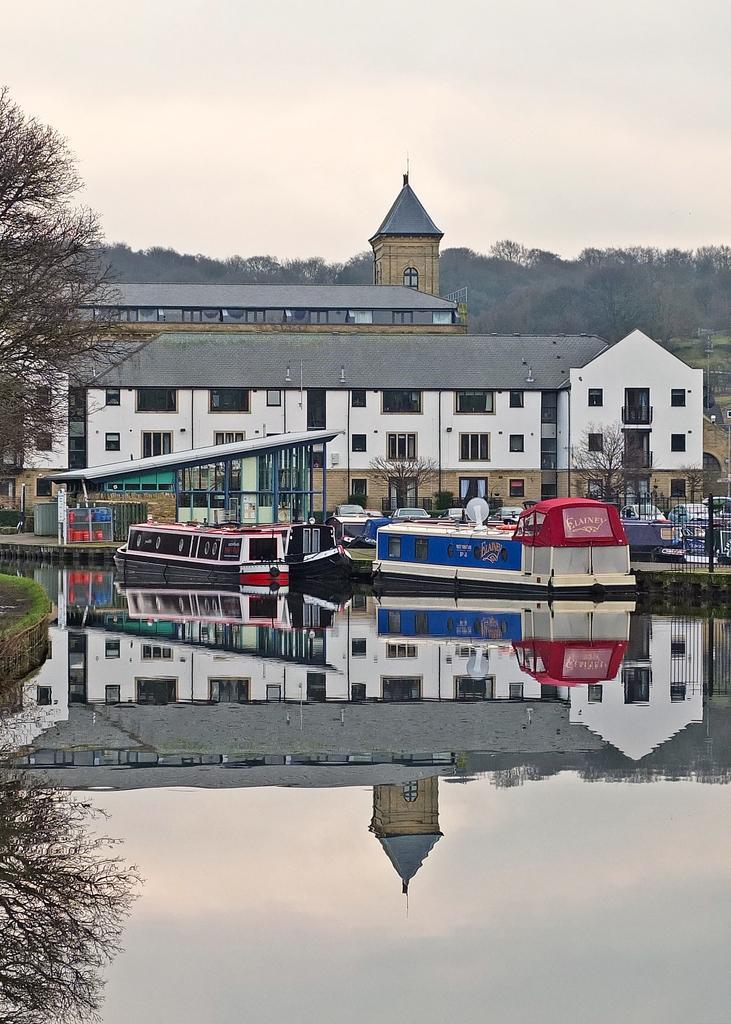Please provide a concise description of this image. In this picture we can see water. There is the reflection of a building and a tree in the water. We can see a few plants and a wall on the left side. There is a fence, trees and buildings in the background. 